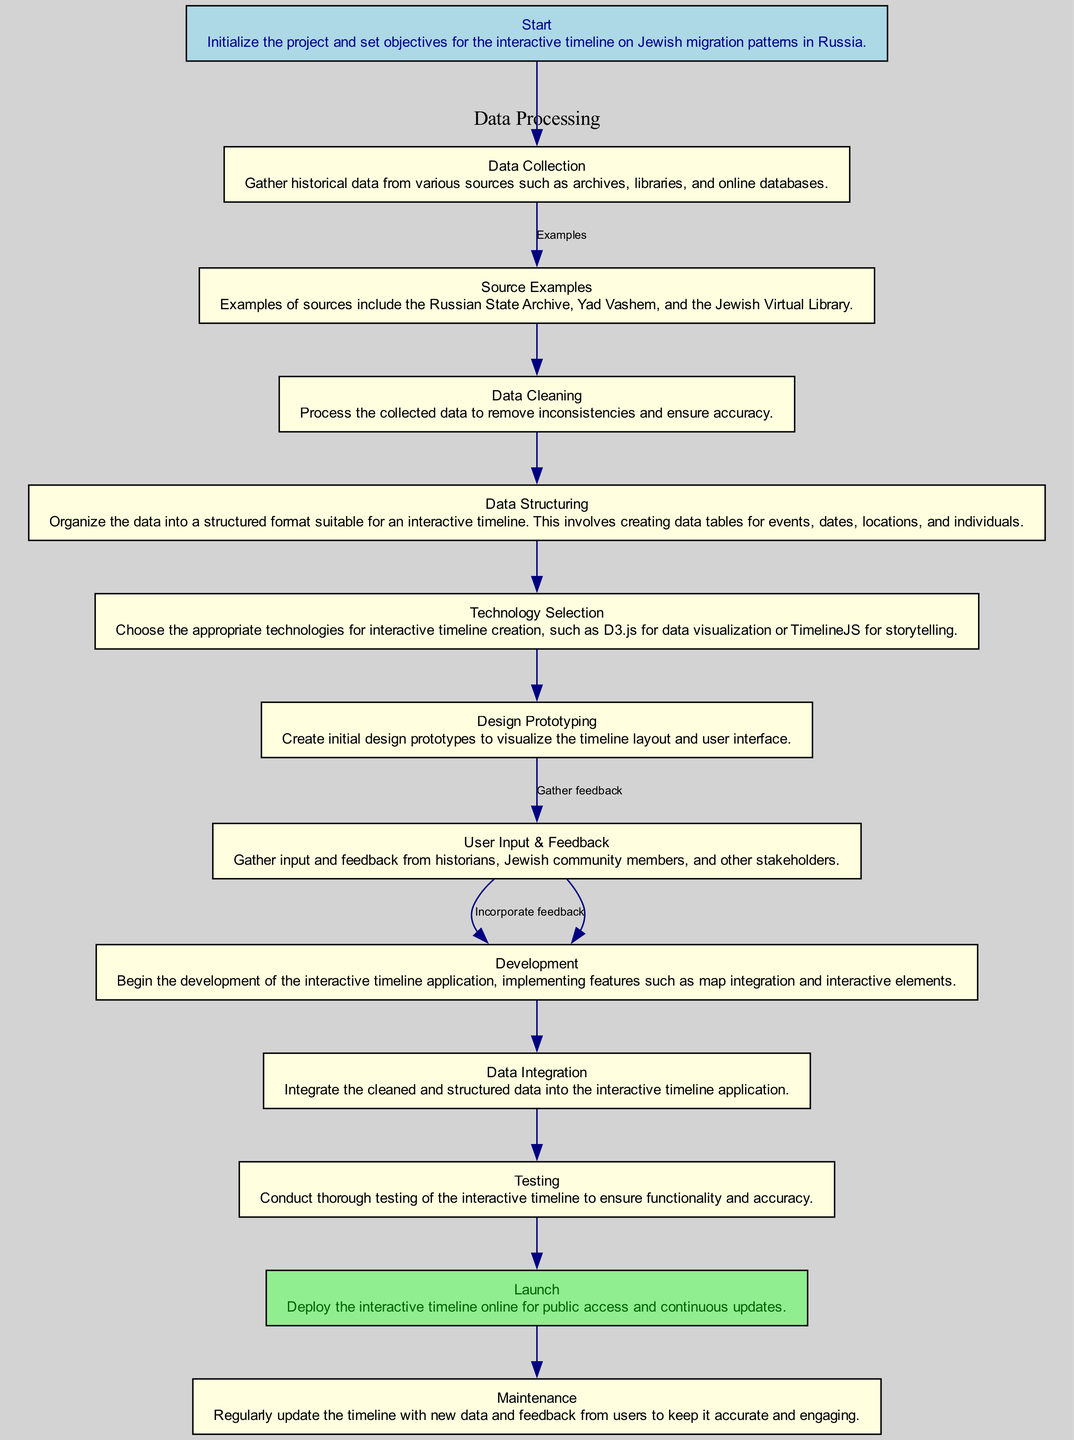What is the first step in the timeline creation process? The first step is labeled "Start", which initializes the project and sets objectives for the interactive timeline on Jewish migration patterns in Russia.
Answer: Start How many nodes are there in the diagram? Counting the steps from "Start" to "Maintenance", there are a total of 13 nodes representing each step in the process.
Answer: 13 What is the last step in the process? The last step is labeled "Maintenance", which involves regularly updating the timeline with new data and user feedback.
Answer: Maintenance Which node follows "User Input & Feedback"? The node that follows "User Input & Feedback" is "Development", indicating that after gathering feedback, development of the application begins.
Answer: Development Which node is highlighted in light green? The node that is highlighted in light green is "Launch", indicating its importance in the overall timeline creation process.
Answer: Launch What action is taken after the "Data Integration"? After "Data Integration", the next action taken is "Testing", indicating the sequence in which the interactive timeline undergoes testing for functionality and accuracy.
Answer: Testing Which two nodes are connected by the edge labeled "Incorporate feedback"? The edge labeled "Incorporate feedback" connects the nodes "User Input & Feedback" and "Development", illustrating the flow from gathering input to implementing it.
Answer: User Input & Feedback, Development What is the purpose of the "Design Prototyping" step? The "Design Prototyping" step is intended to create initial design prototypes to visualize the timeline layout and user interface.
Answer: Create initial design prototypes What source is mentioned as an example in the "Source Examples" node? One example of a source mentioned is the "Russian State Archive", indicating where historical data can be gathered for the timeline.
Answer: Russian State Archive 